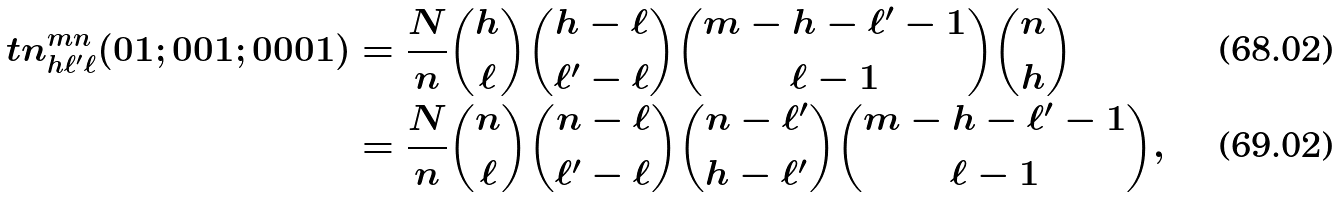<formula> <loc_0><loc_0><loc_500><loc_500>\ t n ^ { m n } _ { h \ell ^ { \prime } \ell } ( 0 1 ; 0 0 1 ; 0 0 0 1 ) & = \frac { N } { n } \binom { h } { \ell } \binom { h - \ell } { \ell ^ { \prime } - \ell } \binom { m - h - \ell ^ { \prime } - 1 } { \ell - 1 } \binom { n } { h } \\ & = \frac { N } { n } \binom { n } { \ell } \binom { n - \ell } { \ell ^ { \prime } - \ell } \binom { n - \ell ^ { \prime } } { h - \ell ^ { \prime } } \binom { m - h - \ell ^ { \prime } - 1 } { \ell - 1 } ,</formula> 